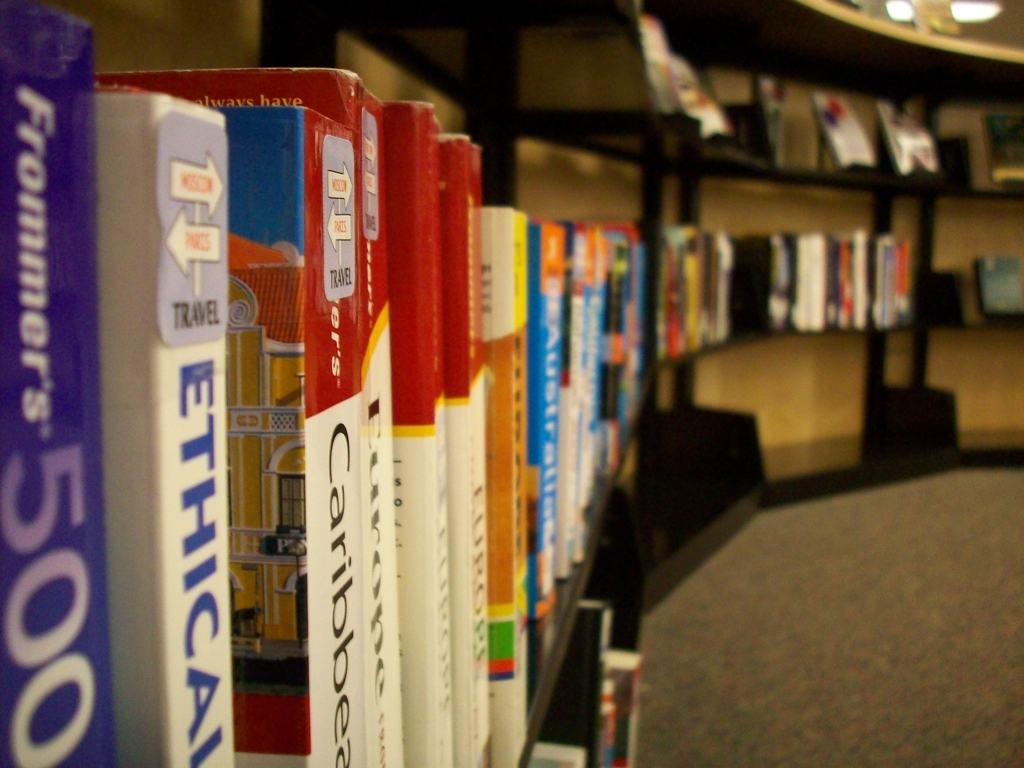What impression does the arrangement of books give? The arrangement of books with their spines facing outward is methodical and orderly, designed to maximize visibility for titles while efficiently utilizing the available shelf space. This setup invites readers to peruse and find books of interest easily. 